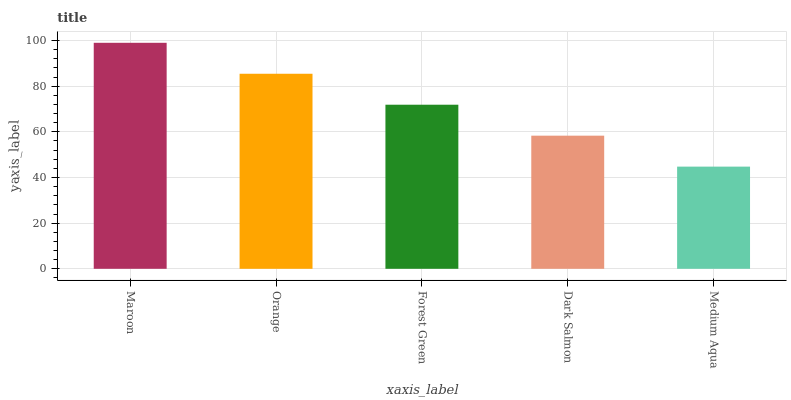Is Medium Aqua the minimum?
Answer yes or no. Yes. Is Maroon the maximum?
Answer yes or no. Yes. Is Orange the minimum?
Answer yes or no. No. Is Orange the maximum?
Answer yes or no. No. Is Maroon greater than Orange?
Answer yes or no. Yes. Is Orange less than Maroon?
Answer yes or no. Yes. Is Orange greater than Maroon?
Answer yes or no. No. Is Maroon less than Orange?
Answer yes or no. No. Is Forest Green the high median?
Answer yes or no. Yes. Is Forest Green the low median?
Answer yes or no. Yes. Is Medium Aqua the high median?
Answer yes or no. No. Is Maroon the low median?
Answer yes or no. No. 